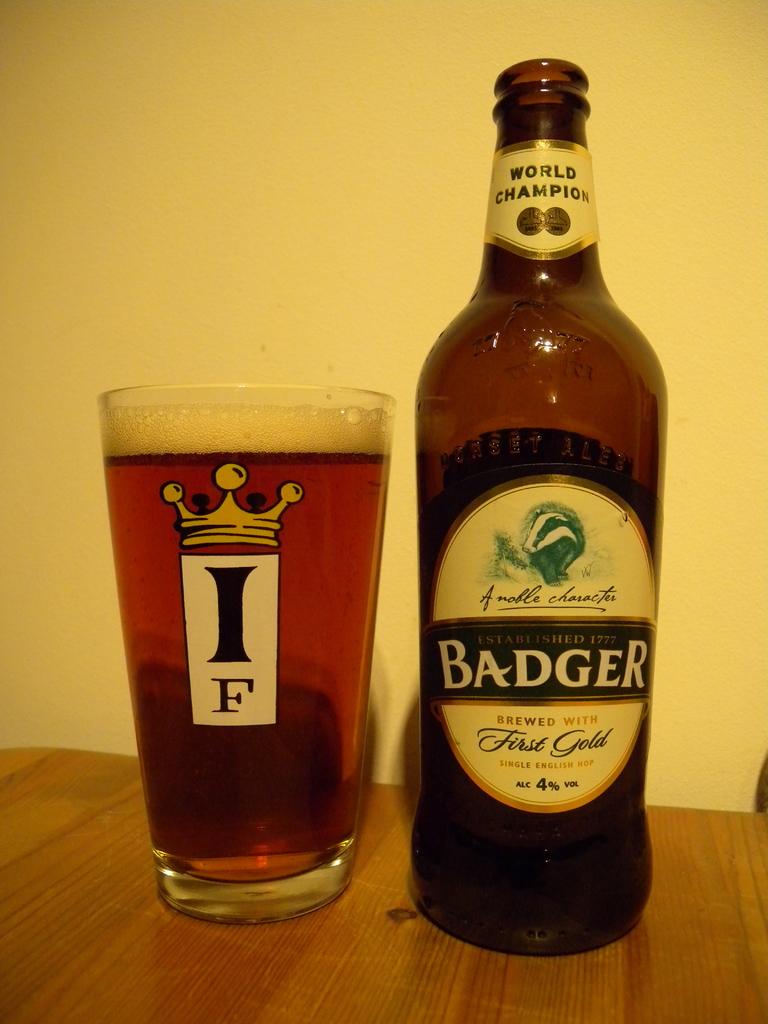What do the bottles contain?
Your response must be concise. Beer. 